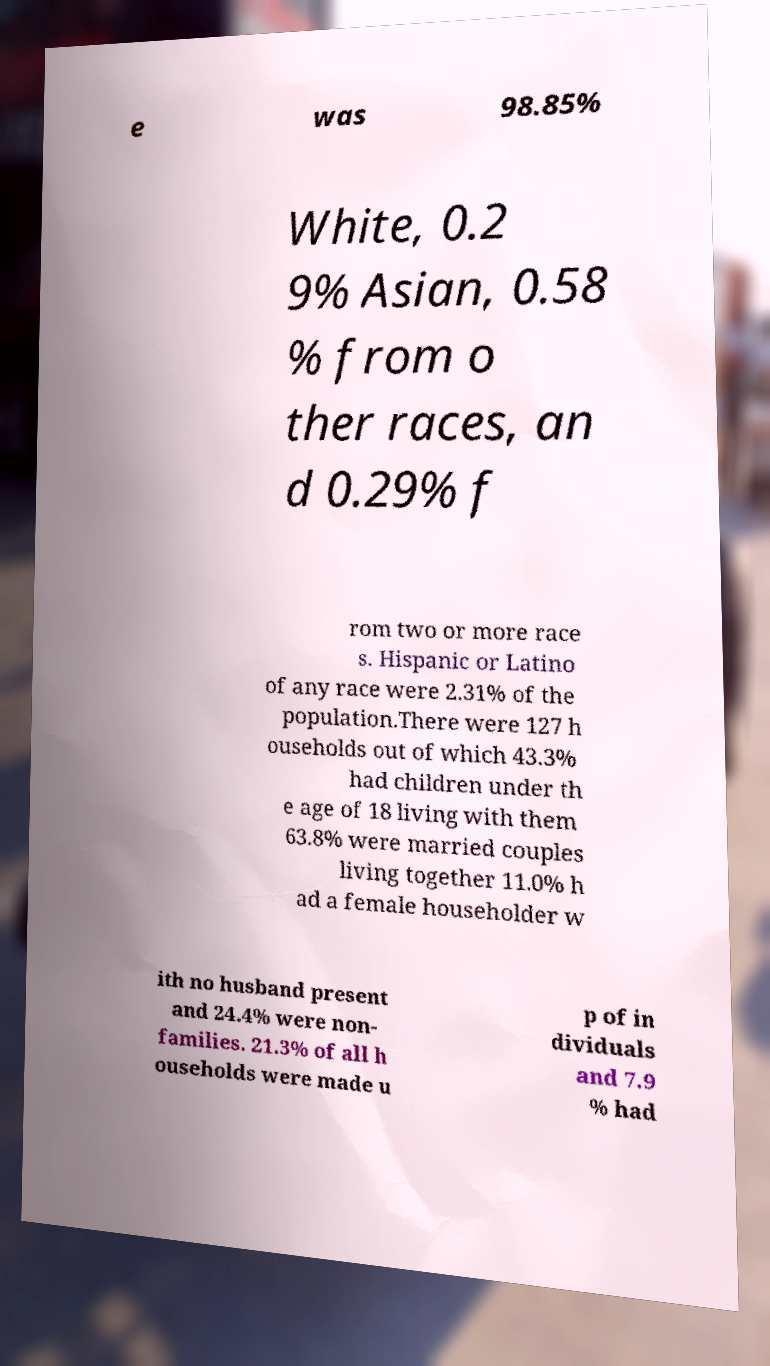Could you extract and type out the text from this image? e was 98.85% White, 0.2 9% Asian, 0.58 % from o ther races, an d 0.29% f rom two or more race s. Hispanic or Latino of any race were 2.31% of the population.There were 127 h ouseholds out of which 43.3% had children under th e age of 18 living with them 63.8% were married couples living together 11.0% h ad a female householder w ith no husband present and 24.4% were non- families. 21.3% of all h ouseholds were made u p of in dividuals and 7.9 % had 